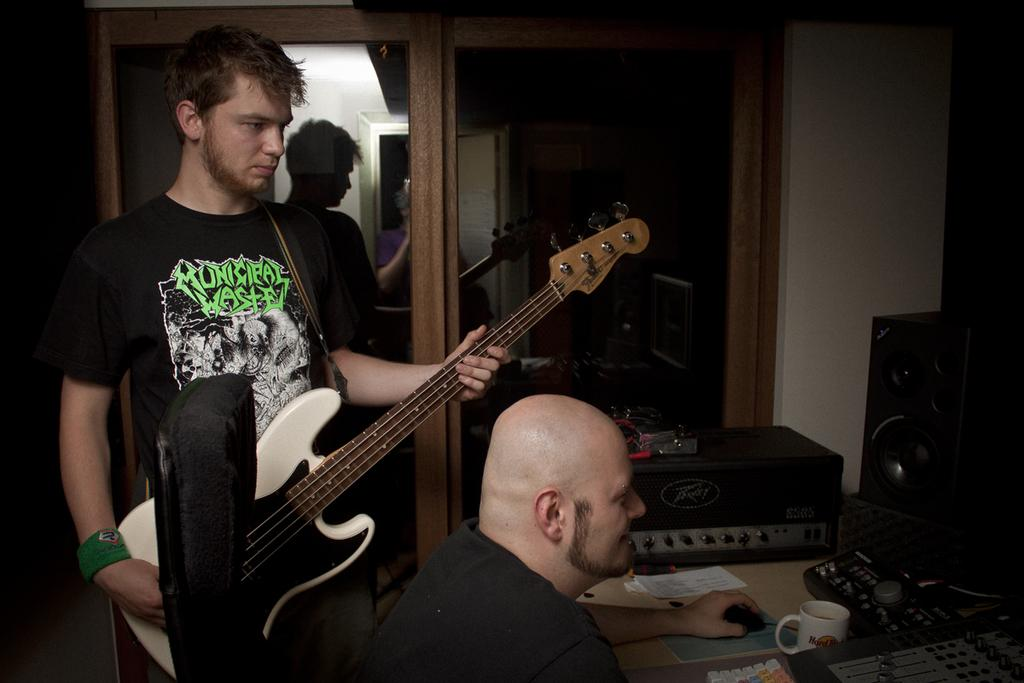How many people are in the image? There are two people in the image. What is one person doing in the image? One person is standing and holding a guitar. What is the other person doing in the image? The other person is sitting on a chair and playing a musical instrument. What type of ship can be seen in the background of the image? There is no ship present in the image; it features two people, one standing with a guitar and the other sitting and playing a musical instrument. 